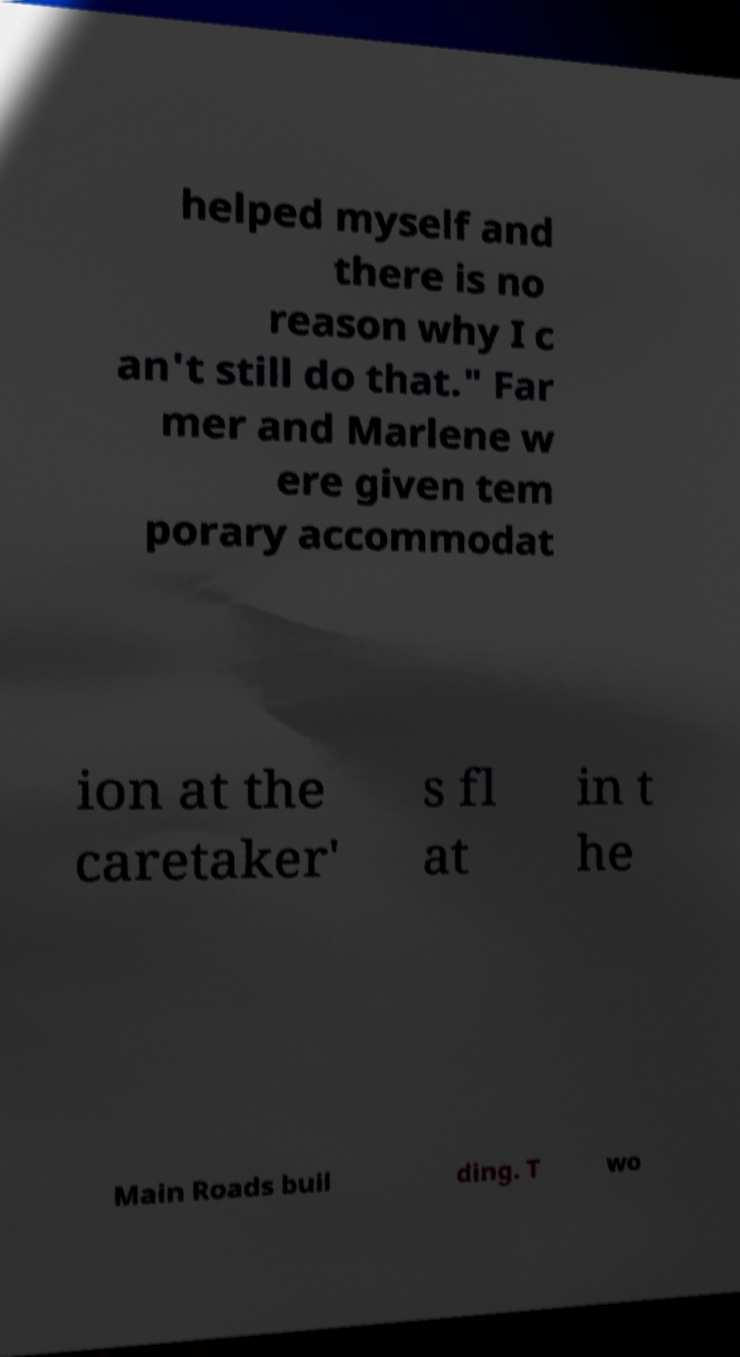Please identify and transcribe the text found in this image. helped myself and there is no reason why I c an't still do that." Far mer and Marlene w ere given tem porary accommodat ion at the caretaker' s fl at in t he Main Roads buil ding. T wo 